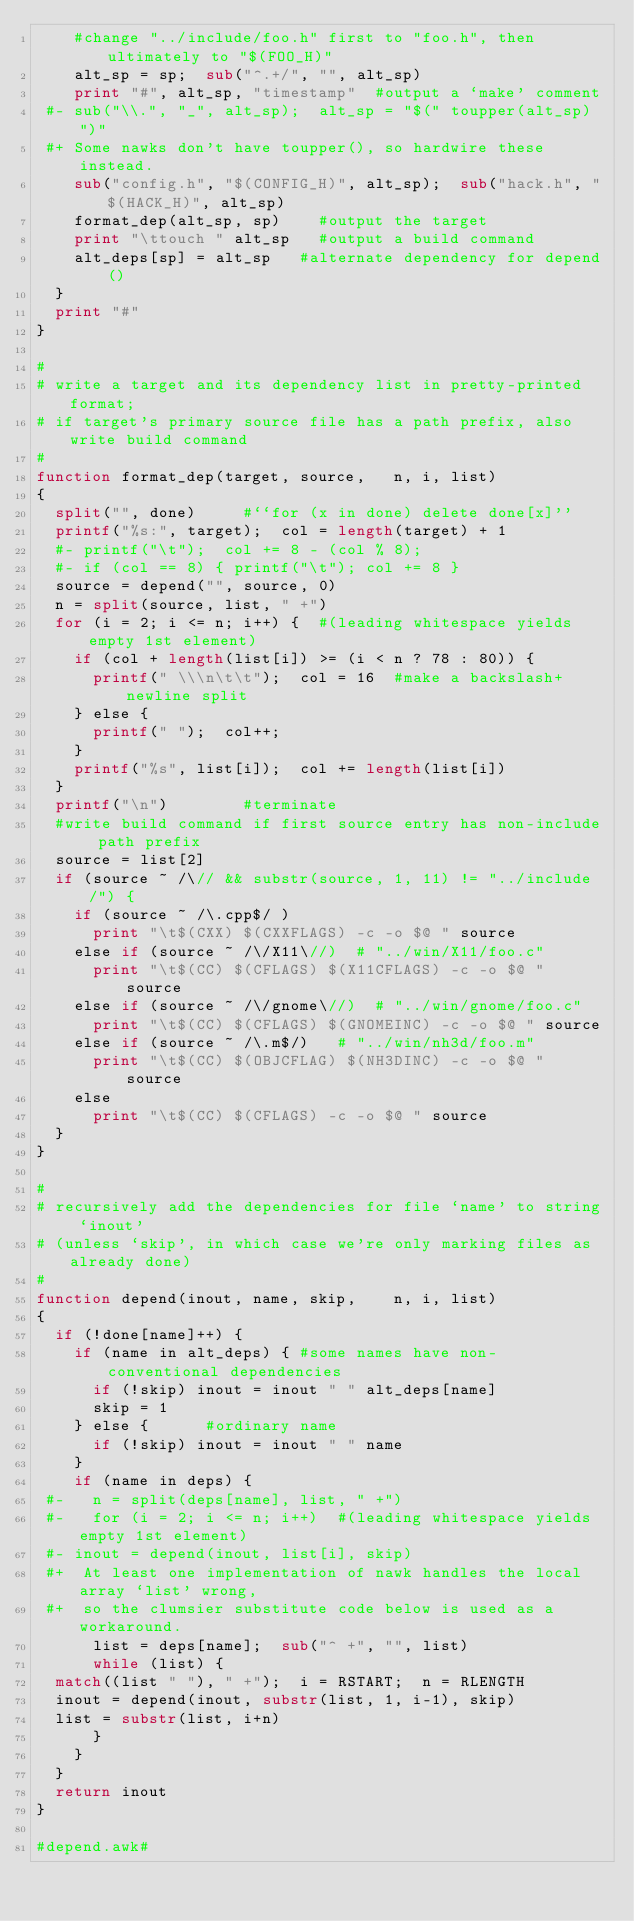<code> <loc_0><loc_0><loc_500><loc_500><_Awk_>    #change "../include/foo.h" first to "foo.h", then ultimately to "$(FOO_H)"
    alt_sp = sp;  sub("^.+/", "", alt_sp)
    print "#", alt_sp, "timestamp"	#output a `make' comment
 #- sub("\\.", "_", alt_sp);  alt_sp = "$(" toupper(alt_sp) ")"
 #+ Some nawks don't have toupper(), so hardwire these instead.
    sub("config.h", "$(CONFIG_H)", alt_sp);  sub("hack.h", "$(HACK_H)", alt_sp)
    format_dep(alt_sp, sp)		#output the target
    print "\ttouch " alt_sp		#output a build command
    alt_deps[sp] = alt_sp		#alternate dependency for depend()
  }
  print "#"
}

#
# write a target and its dependency list in pretty-printed format;
# if target's primary source file has a path prefix, also write build command
#
function format_dep(target, source,		n, i, list)
{
  split("", done)			#``for (x in done) delete done[x]''
  printf("%s:", target);  col = length(target) + 1
  #- printf("\t");  col += 8 - (col % 8);
  #- if (col == 8) { printf("\t"); col += 8 }
  source = depend("", source, 0)
  n = split(source, list, " +")
  for (i = 2; i <= n; i++) {	#(leading whitespace yields empty 1st element)
    if (col + length(list[i]) >= (i < n ? 78 : 80)) {
      printf(" \\\n\t\t");  col = 16	#make a backslash+newline split
    } else {
      printf(" ");  col++;
    }
    printf("%s", list[i]);  col += length(list[i])
  }
  printf("\n")				#terminate
  #write build command if first source entry has non-include path prefix
  source = list[2]
  if (source ~ /\// && substr(source, 1, 11) != "../include/") {
    if (source ~ /\.cpp$/ )
      print "\t$(CXX) $(CXXFLAGS) -c -o $@ " source
    else if (source ~ /\/X11\//)	# "../win/X11/foo.c"
      print "\t$(CC) $(CFLAGS) $(X11CFLAGS) -c -o $@ " source
    else if (source ~ /\/gnome\//)	# "../win/gnome/foo.c"
      print "\t$(CC) $(CFLAGS) $(GNOMEINC) -c -o $@ " source
    else if (source ~ /\.m$/)		# "../win/nh3d/foo.m"
      print "\t$(CC) $(OBJCFLAG) $(NH3DINC) -c -o $@ " source
    else
      print "\t$(CC) $(CFLAGS) -c -o $@ " source
  }
}

#
# recursively add the dependencies for file `name' to string `inout'
# (unless `skip', in which case we're only marking files as already done)
#
function depend(inout, name, skip,		n, i, list)
{
  if (!done[name]++) {
    if (name in alt_deps) {	#some names have non-conventional dependencies
      if (!skip) inout = inout " " alt_deps[name]
      skip = 1
    } else {			#ordinary name
      if (!skip) inout = inout " " name
    }
    if (name in deps) {
 #-   n = split(deps[name], list, " +")
 #-   for (i = 2; i <= n; i++)	#(leading whitespace yields empty 1st element)
 #-	inout = depend(inout, list[i], skip)
 #+  At least one implementation of nawk handles the local array `list' wrong,
 #+  so the clumsier substitute code below is used as a workaround.
      list = deps[name];  sub("^ +", "", list)
      while (list) {
	match((list " "), " +");  i = RSTART;  n = RLENGTH
	inout = depend(inout, substr(list, 1, i-1), skip)
	list = substr(list, i+n)
      }
    }
  }
  return inout
}

#depend.awk#
</code> 